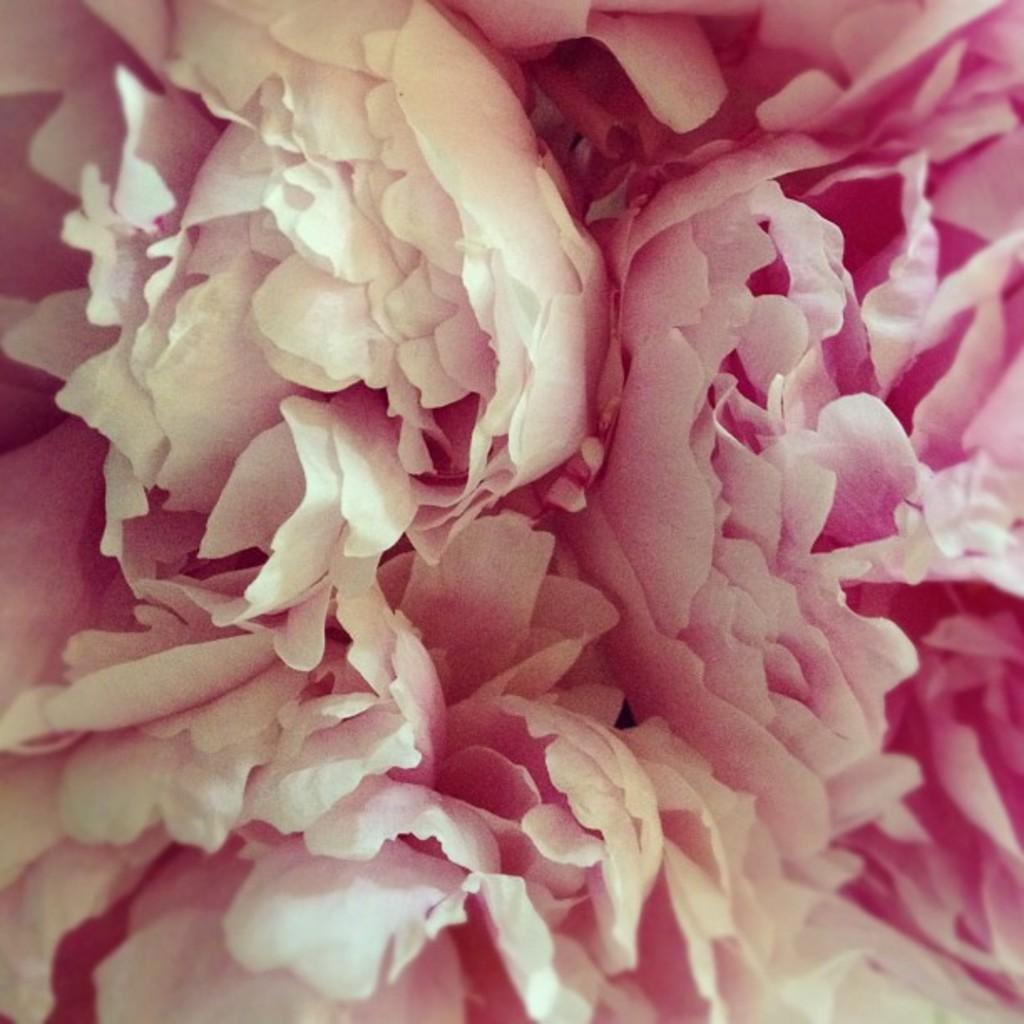What type of living organisms can be seen in the image? There are flowers in the image. What colors are the flowers in the image? The flowers are in white and pink colors. What type of meat is being served on the desk in the image? There is no meat or desk present in the image; it features flowers in white and pink colors. 